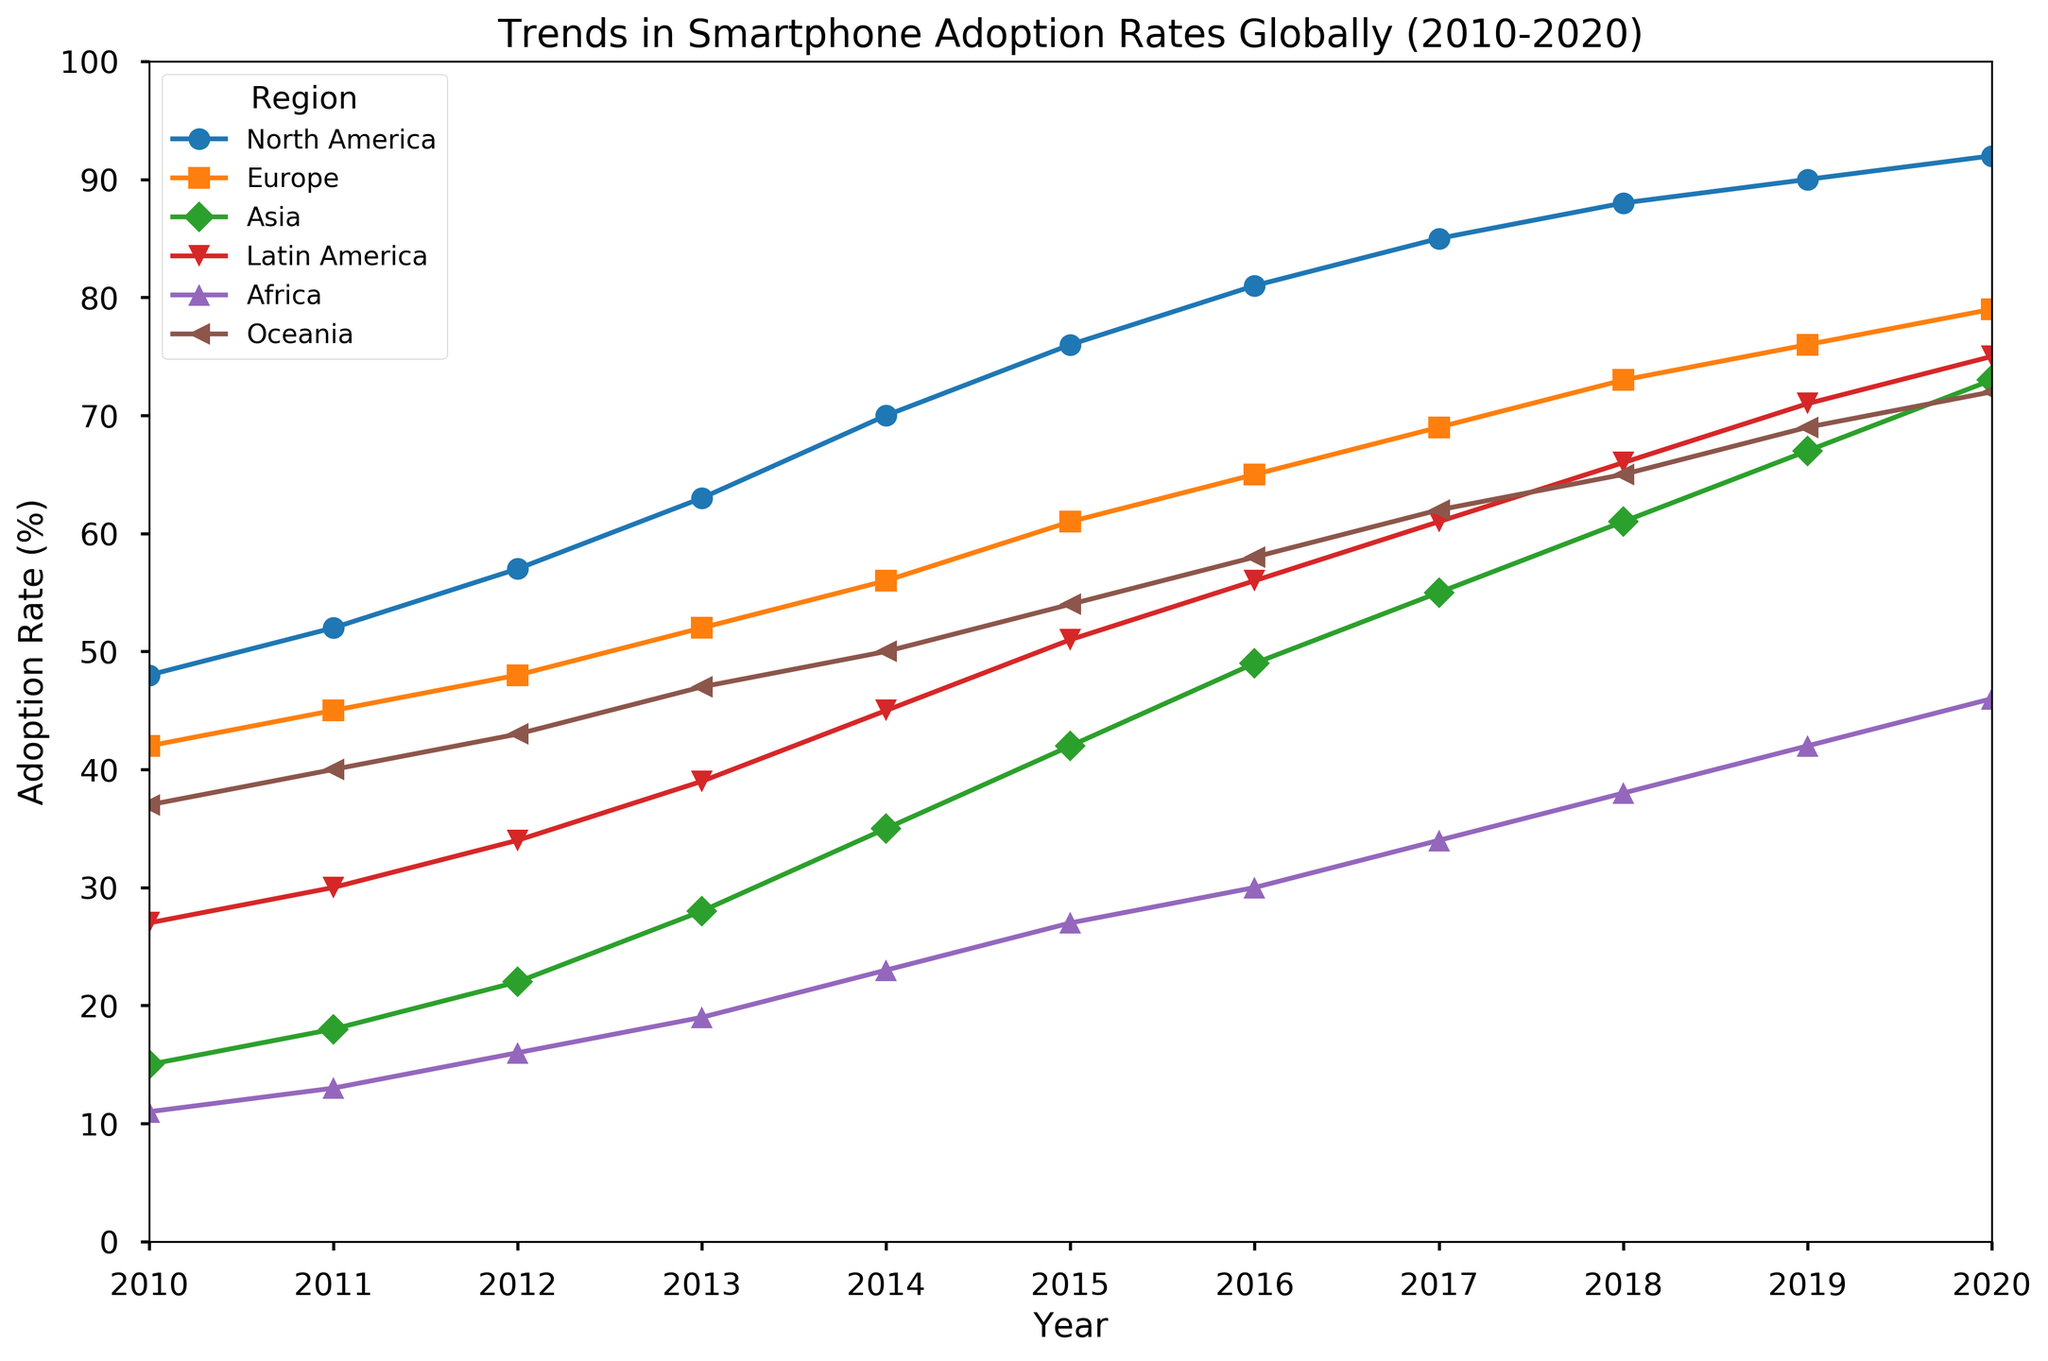What was the adoption rate in North America in 2015? To find this, locate the data point for North America corresponding to the year 2015 on the x-axis.
Answer: 76% Which region had the highest adoption rate in 2013 and what was it? Check the data points for all regions in the year 2013 and compare their values to find the highest one.
Answer: North America, 63% Which two regions showed the most significant growth in smartphone adoption rates from 2010 to 2020? Examine the trend lines for all regions and identify those with the steepest slopes or largest differences in adoption rates between 2010 and 2020.
Answer: Asia and Africa What's the average smartphone adoption rate in Europe between 2010 and 2020? Add the yearly adoption rates in Europe from 2010 to 2020 and divide by the number of years (11). (42 + 45 + 48 + 52 + 56 + 61 + 65 + 69 + 73 + 76 + 79) / 11 = 676 / 11
Answer: 61.45% In what year did Latin America surpass an adoption rate of 50%? Observe the trend line for Latin America and identify the first year when the adoption rate exceeds the 50% mark.
Answer: 2015 Compare the smartphone adoption rates of North America and Europe in 2020. Which region had a higher rate and by how much? Note the adoption rates of North America and Europe in 2020, then subtract the European rate from the North American rate. (92 - 79)
Answer: North America; 13% By how much did Africa's smartphone adoption rate increase from 2010 to 2014? Subtract Africa's adoption rate in 2010 from the rate in 2014. (23 - 11 )
Answer: 12% How does the adoption rate in Oceania in 2012 compare to that in 2019? Check the data points for Oceania in 2012 and 2019 and note the difference. (69 - 43)
Answer: 26% higher Between 2010 and 2020, which region had the smallest overall increase in smartphone adoption rates? Compare the changes in adoption rates from 2010 to 2020 for all regions and identify the smallest one.
Answer: North America What is the median adoption rate for Asia from 2010 to 2020? Write down the adoption rates for Asia from 2010 to 2020, order them, and find the middle value. (15, 18, 22, 28, 35, 42, 49, 55, 61, 67, 73) The middle value is 42.
Answer: 42 